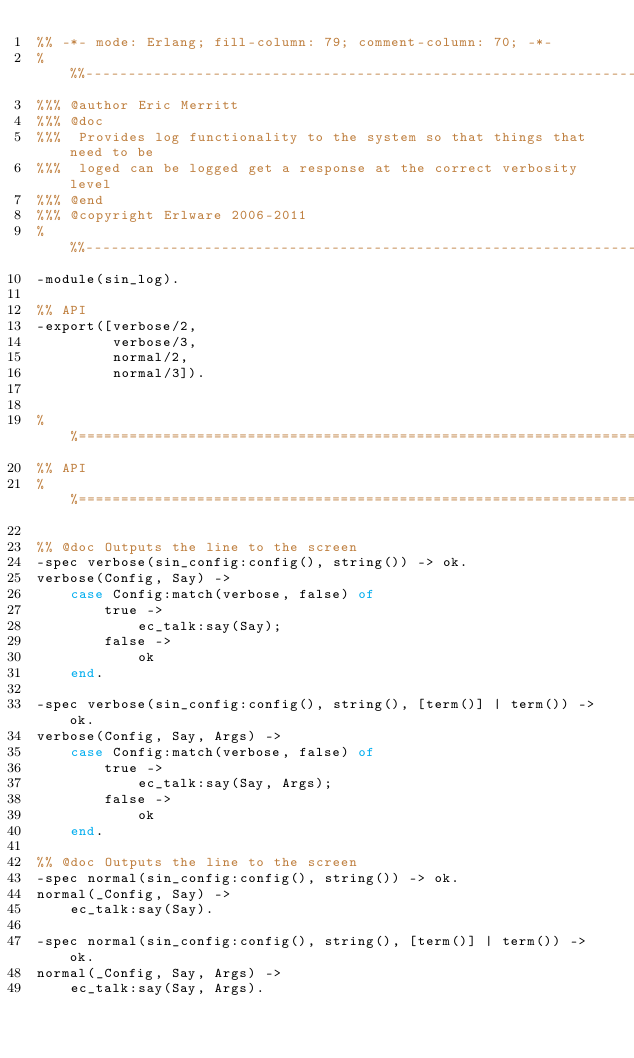<code> <loc_0><loc_0><loc_500><loc_500><_Erlang_>%% -*- mode: Erlang; fill-column: 79; comment-column: 70; -*-
%%%---------------------------------------------------------------------------
%%% @author Eric Merritt
%%% @doc
%%%  Provides log functionality to the system so that things that need to be
%%%  loged can be logged get a response at the correct verbosity level
%%% @end
%%% @copyright Erlware 2006-2011
%%%---------------------------------------------------------------------------
-module(sin_log).

%% API
-export([verbose/2,
         verbose/3,
         normal/2,
         normal/3]).


%%============================================================================
%% API
%%============================================================================

%% @doc Outputs the line to the screen
-spec verbose(sin_config:config(), string()) -> ok.
verbose(Config, Say) ->
    case Config:match(verbose, false) of
        true ->
            ec_talk:say(Say);
        false ->
            ok
    end.

-spec verbose(sin_config:config(), string(), [term()] | term()) -> ok.
verbose(Config, Say, Args) ->
    case Config:match(verbose, false) of
        true ->
            ec_talk:say(Say, Args);
        false ->
            ok
    end.

%% @doc Outputs the line to the screen
-spec normal(sin_config:config(), string()) -> ok.
normal(_Config, Say) ->
    ec_talk:say(Say).

-spec normal(sin_config:config(), string(), [term()] | term()) -> ok.
normal(_Config, Say, Args) ->
    ec_talk:say(Say, Args).



</code> 